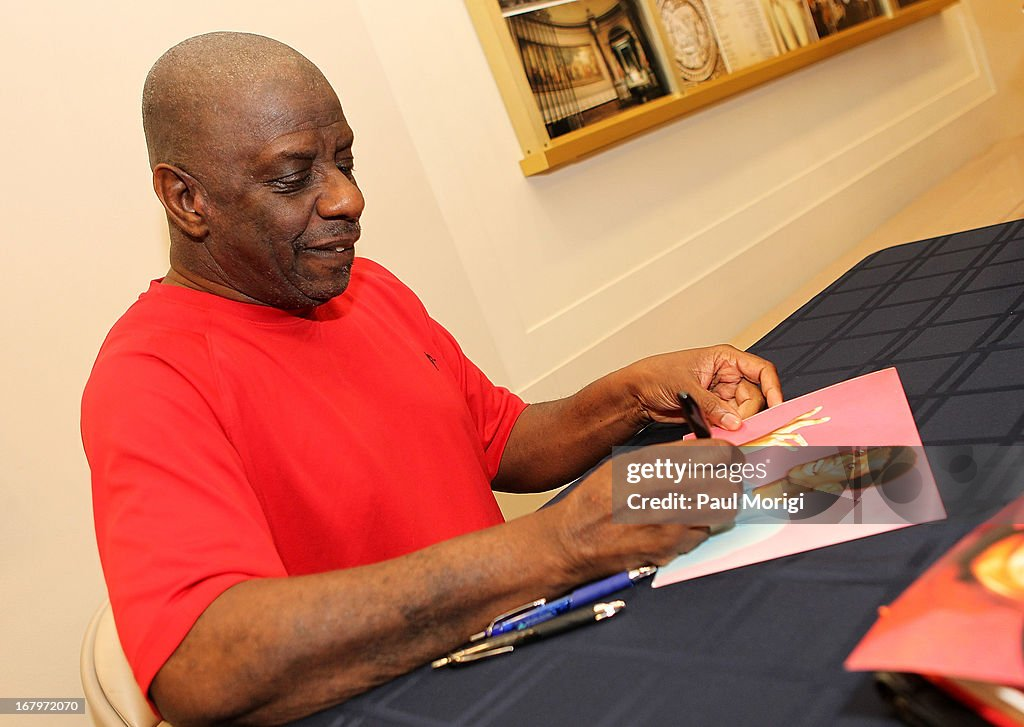Based on the items present on the table and the activity the person is engaged in, what type of event might this individual be participating in, and what role does he likely play in this context? It looks like the individual is participating in an autograph signing event. The presence of the pen, the stack of cards or photographs, and the focused activity of signing items suggest this. Given the setup, he is likely an invited guest, such as an author, artist, or public figure. His role is probably that of the main attraction or featured guest, signing memorabilia for fans or attendees. 